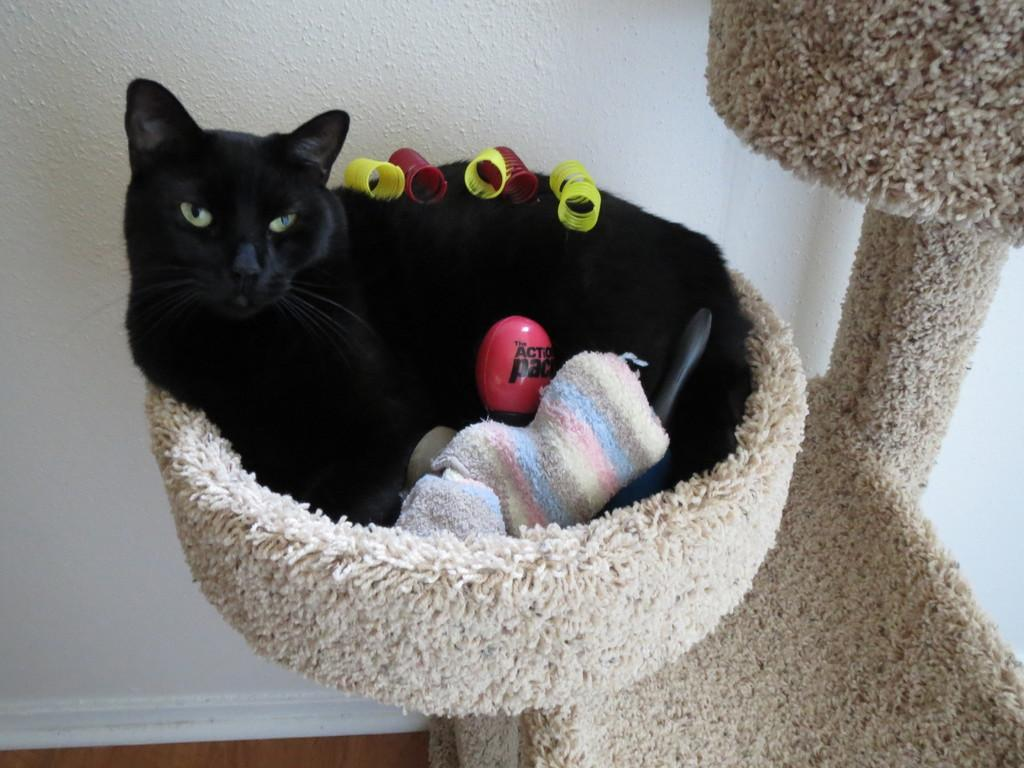What type of animal is in the image? There is a black cat in the image. Where is the cat located? The cat is sitting on a sofa-like structure. What color is the wall in the background of the image? There is a white wall in the background of the image. What type of crops does the farmer grow in the garden depicted in the image? There is no farmer or garden present in the image; it features a black cat sitting on a sofa-like structure with a white wall in the background. 